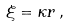Convert formula to latex. <formula><loc_0><loc_0><loc_500><loc_500>\xi = \kappa r \, ,</formula> 